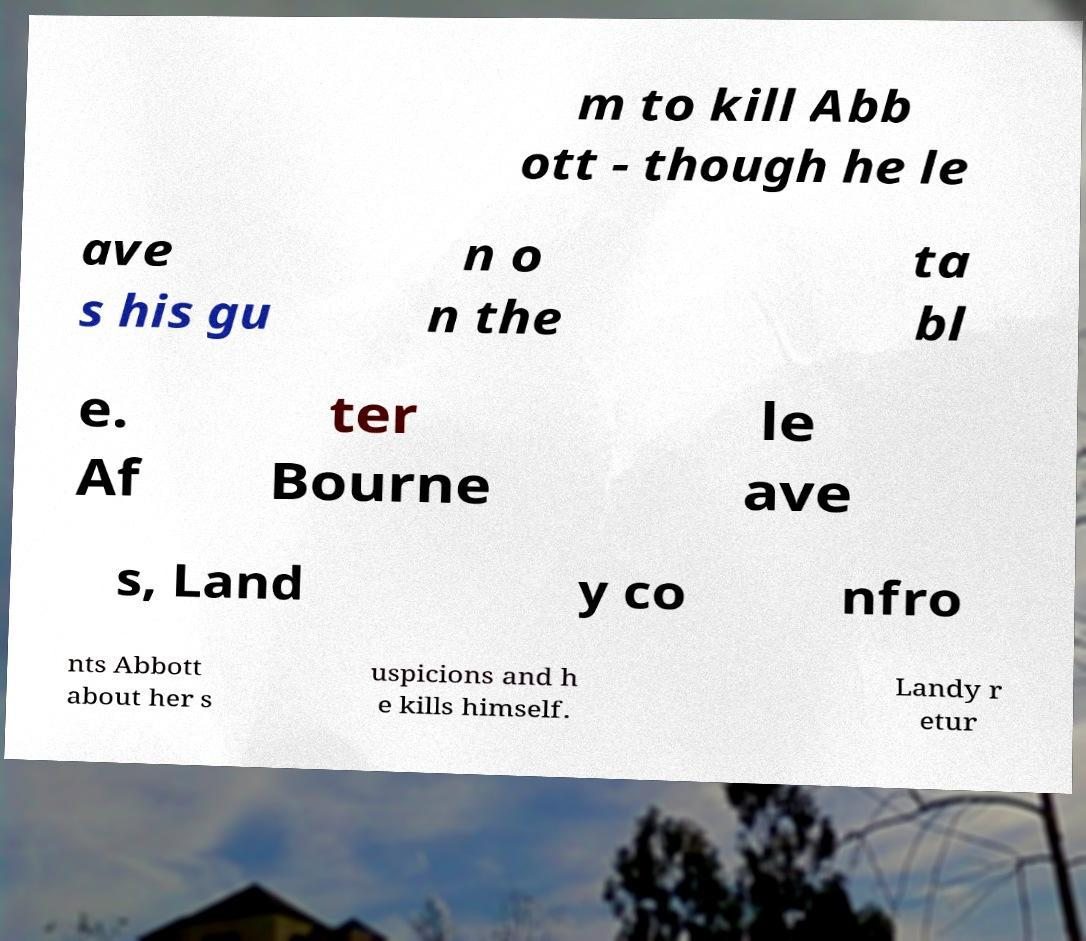What messages or text are displayed in this image? I need them in a readable, typed format. m to kill Abb ott - though he le ave s his gu n o n the ta bl e. Af ter Bourne le ave s, Land y co nfro nts Abbott about her s uspicions and h e kills himself. Landy r etur 